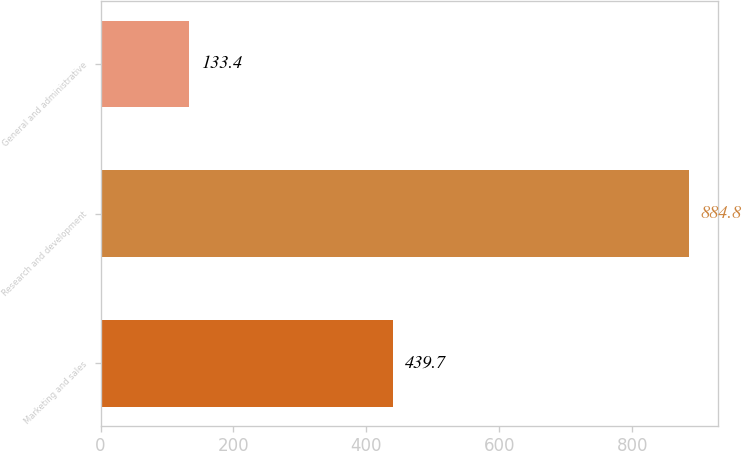<chart> <loc_0><loc_0><loc_500><loc_500><bar_chart><fcel>Marketing and sales<fcel>Research and development<fcel>General and administrative<nl><fcel>439.7<fcel>884.8<fcel>133.4<nl></chart> 